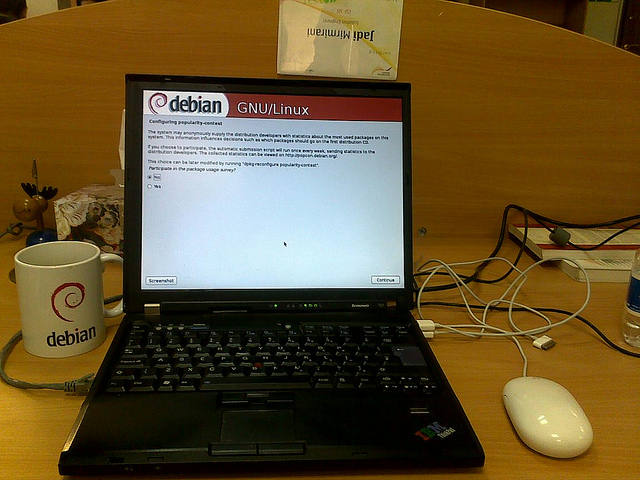Read all the text in this image. debian debian GNU/Linux Jadi Mirmirani 